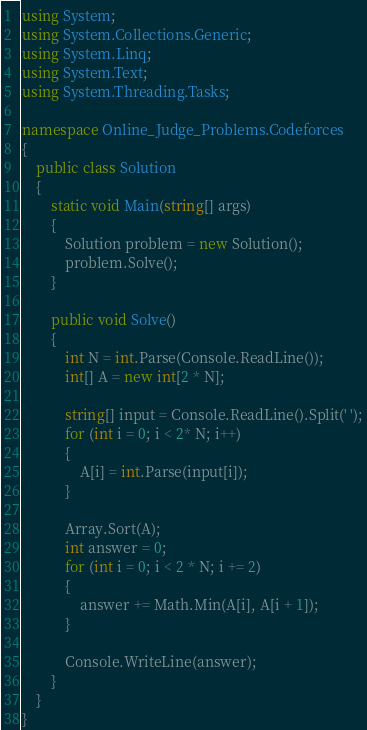Convert code to text. <code><loc_0><loc_0><loc_500><loc_500><_C#_>using System;
using System.Collections.Generic;
using System.Linq;
using System.Text;
using System.Threading.Tasks;

namespace Online_Judge_Problems.Codeforces
{
    public class Solution
    {
		static void Main(string[] args)
        {
            Solution problem = new Solution();
            problem.Solve();
        }
		
		public void Solve()
        {
            int N = int.Parse(Console.ReadLine());
            int[] A = new int[2 * N];

            string[] input = Console.ReadLine().Split(' ');
            for (int i = 0; i < 2* N; i++)
            {
                A[i] = int.Parse(input[i]);
            }

            Array.Sort(A);
            int answer = 0;
            for (int i = 0; i < 2 * N; i += 2)
            {
                answer += Math.Min(A[i], A[i + 1]);
            }

            Console.WriteLine(answer);
        }
    }
}
</code> 